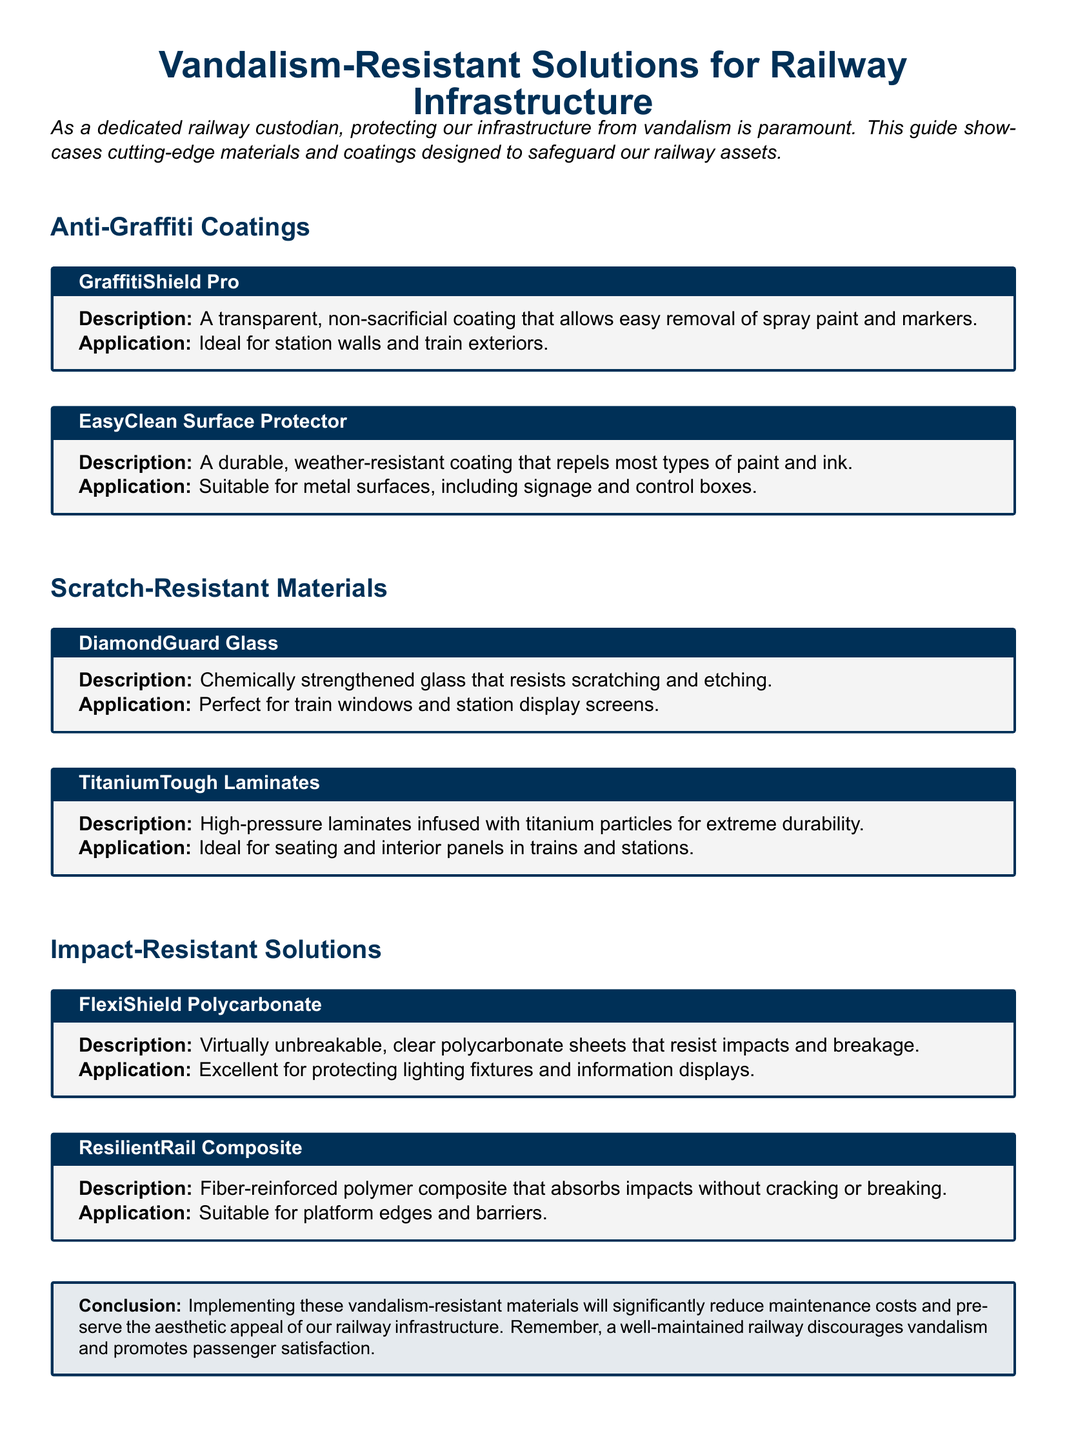What is the first product listed under Anti-Graffiti Coatings? The first product listed provides the name of the product in the Anti-Graffiti Coatings section.
Answer: GraffitiShield Pro What type of coating is EasyClean Surface Protector? The document specifies the type of coating provided for EasyClean Surface Protector.
Answer: Durable, weather-resistant coating What type of glass is DiamondGuard Glass? This question refers to the material used in DiamondGuard Glass as mentioned in the document.
Answer: Chemically strengthened glass Which material is designed for seating and interior panels? The answer will indicate which material specifically mentions its application for seating and interior panels.
Answer: TitaniumTough Laminates What are FlexiShield Polycarbonate sheets known for? The document mentions the primary attribute of FlexiShield Polycarbonate sheets.
Answer: Virtually unbreakable How does ResilientRail Composite behave under impact? The answer summarizes the behavior of ResilientRail Composite when subjected to impact, as described in the document.
Answer: Absorbs impacts without cracking or breaking What is the conclusion's emphasis in the document? The conclusion discusses the main benefit of implementing vandalism-resistant materials.
Answer: Reduce maintenance costs How many types of coatings are presented in the document? This question asks for a count of different types of coatings listed in the document based on sections.
Answer: Two types 